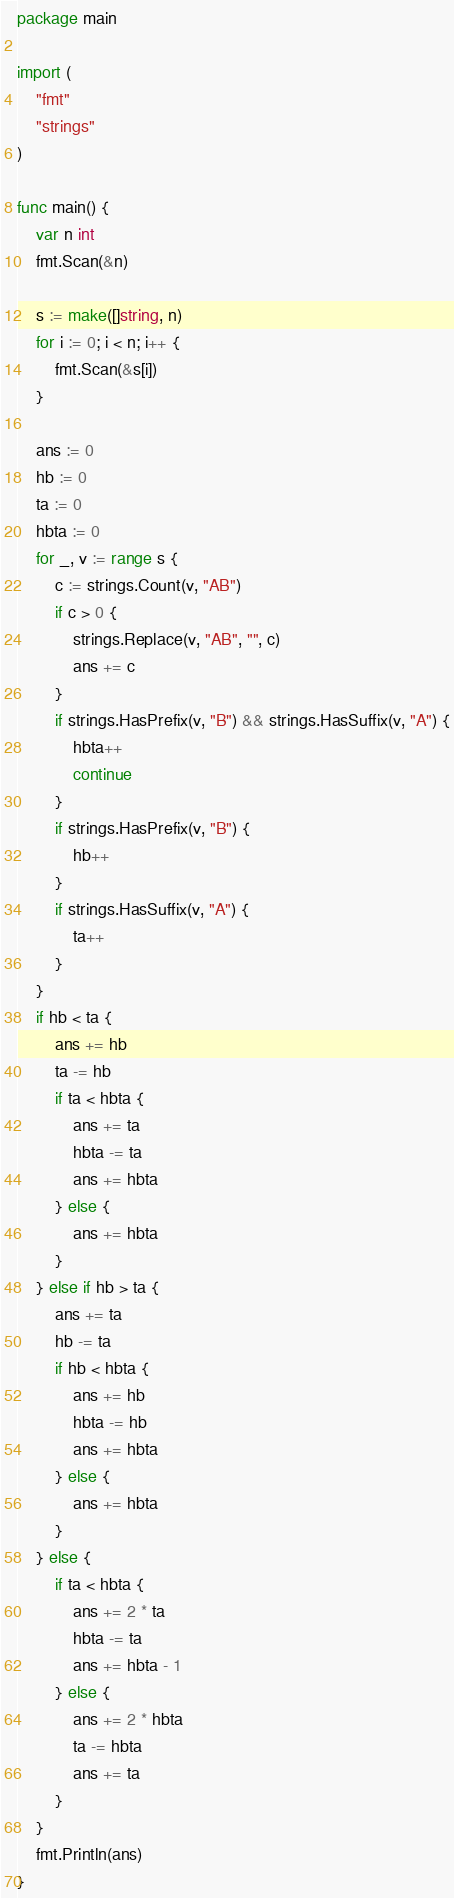<code> <loc_0><loc_0><loc_500><loc_500><_Go_>package main

import (
	"fmt"
	"strings"
)

func main() {
	var n int
	fmt.Scan(&n)

	s := make([]string, n)
	for i := 0; i < n; i++ {
		fmt.Scan(&s[i])
	}

	ans := 0
	hb := 0
	ta := 0
	hbta := 0
	for _, v := range s {
		c := strings.Count(v, "AB")
		if c > 0 {
			strings.Replace(v, "AB", "", c)
			ans += c
		}
		if strings.HasPrefix(v, "B") && strings.HasSuffix(v, "A") {
			hbta++
			continue
		}
		if strings.HasPrefix(v, "B") {
			hb++
		}
		if strings.HasSuffix(v, "A") {
			ta++
		}
	}
	if hb < ta {
		ans += hb
		ta -= hb
		if ta < hbta {
			ans += ta
			hbta -= ta
			ans += hbta
		} else {
			ans += hbta
		}
	} else if hb > ta {
		ans += ta
		hb -= ta
		if hb < hbta {
			ans += hb
			hbta -= hb
			ans += hbta
		} else {
			ans += hbta
		}
	} else {
		if ta < hbta {
			ans += 2 * ta
			hbta -= ta
			ans += hbta - 1
		} else {
			ans += 2 * hbta
			ta -= hbta
			ans += ta
		}
	}
	fmt.Println(ans)
}
</code> 